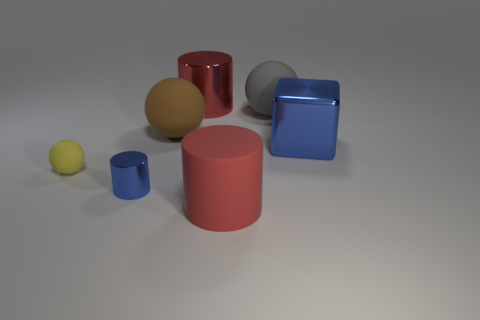Add 2 gray spheres. How many objects exist? 9 Subtract all blocks. How many objects are left? 6 Add 5 big rubber spheres. How many big rubber spheres exist? 7 Subtract 0 purple cylinders. How many objects are left? 7 Subtract all small cylinders. Subtract all tiny yellow balls. How many objects are left? 5 Add 3 brown rubber spheres. How many brown rubber spheres are left? 4 